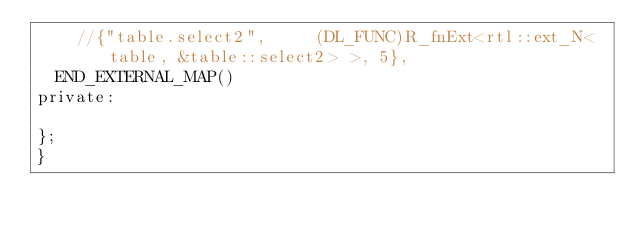Convert code to text. <code><loc_0><loc_0><loc_500><loc_500><_C_>    //{"table.select2",     (DL_FUNC)R_fnExt<rtl::ext_N<table, &table::select2> >, 5},
  END_EXTERNAL_MAP()
private:

};
}
</code> 